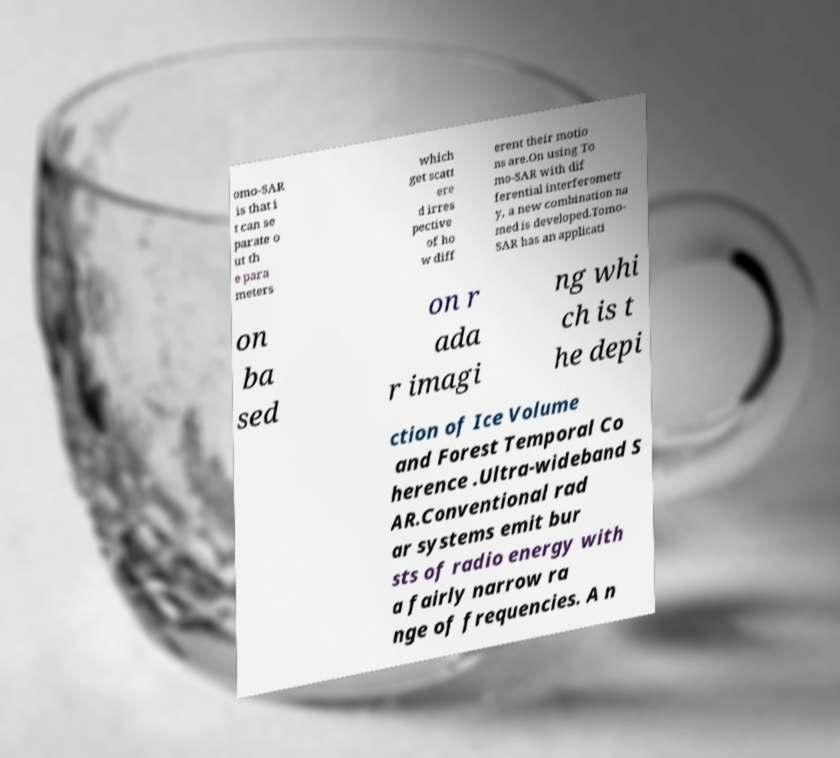Can you accurately transcribe the text from the provided image for me? omo-SAR is that i t can se parate o ut th e para meters which get scatt ere d irres pective of ho w diff erent their motio ns are.On using To mo-SAR with dif ferential interferometr y, a new combination na med is developed.Tomo- SAR has an applicati on ba sed on r ada r imagi ng whi ch is t he depi ction of Ice Volume and Forest Temporal Co herence .Ultra-wideband S AR.Conventional rad ar systems emit bur sts of radio energy with a fairly narrow ra nge of frequencies. A n 